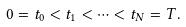<formula> <loc_0><loc_0><loc_500><loc_500>0 = t _ { 0 } < t _ { 1 } < \dots < t _ { N } = T .</formula> 